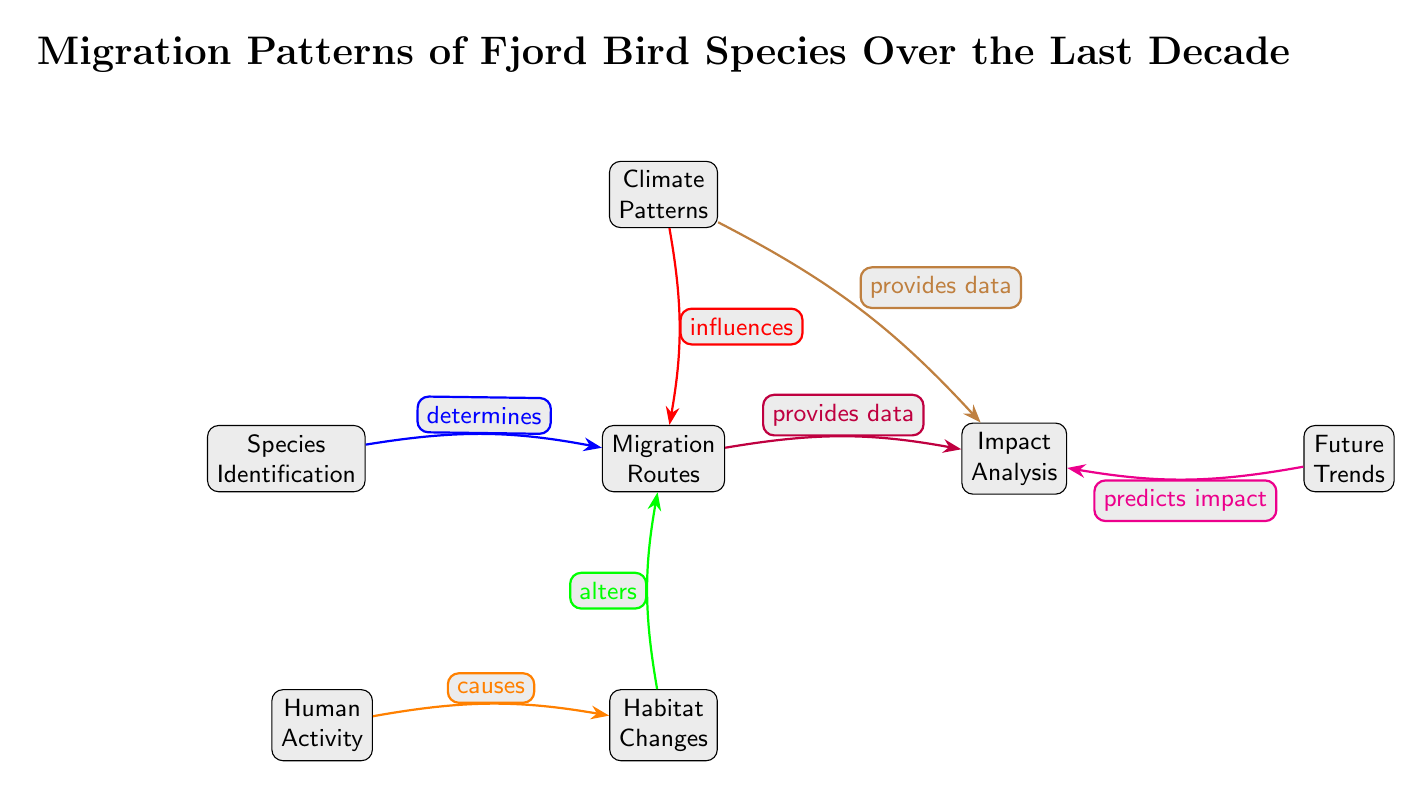What is the title of the diagram? The title is directly at the top of the diagram and reads "Migration Patterns of Fjord Bird Species Over the Last Decade."
Answer: Migration Patterns of Fjord Bird Species Over the Last Decade How many main nodes are present in the diagram? There are six main nodes: Species Identification, Migration Routes, Climate Patterns, Habitat Changes, Human Activity, and Impact Analysis, and Future Trends. Counting these, we find six nodes in total.
Answer: 6 What relationship does "Climate Patterns" have with "Migration Routes"? In the diagram, the arrow connecting "Climate Patterns" to "Migration Routes" is labeled "influences," indicating that climate patterns affect migration routes.
Answer: influences Which node provides data to "Impact Analysis" alongside "Migration Routes"? The edge connecting "Climate Patterns" to "Impact Analysis" is also labeled "provides data." Thus, both "Migration Routes" and "Climate Patterns" furnish data for this node.
Answer: Climate Patterns What causes changes in "Habitat Changes"? "Human Activity" is the source node connected to "Habitat Changes," with the arrow labeled "causes," showing that human activities lead to alterations in habitats.
Answer: Human Activity Which node is affected by both "Habitat Changes" and "Climate Patterns"? "Migration Routes" is connected to both "Habitat Changes" (alters) and "Climate Patterns" (influences), indicating these factors have an impact on migration paths.
Answer: Migration Routes What does the "Future Trends" node predict? The edge leading from "Future Trends" to "Impact Analysis" is labeled "predicts impact," suggesting that future trends are analyzed to forecast their effects.
Answer: predicts impact What two nodes are indicated to have an impact on "Migration Routes"? The arrows show both "Climate Patterns" (influences) and "Habitat Changes" (alters) affecting "Migration Routes," meaning these two factors play a role in determining the routes taken by birds.
Answer: Climate Patterns, Habitat Changes What is the edge relationship between "Species Identification" and "Migration Routes"? The arrow between these nodes is labeled "determines," indicating that the identification of species is a factor that influences or defines their migration routes.
Answer: determines 